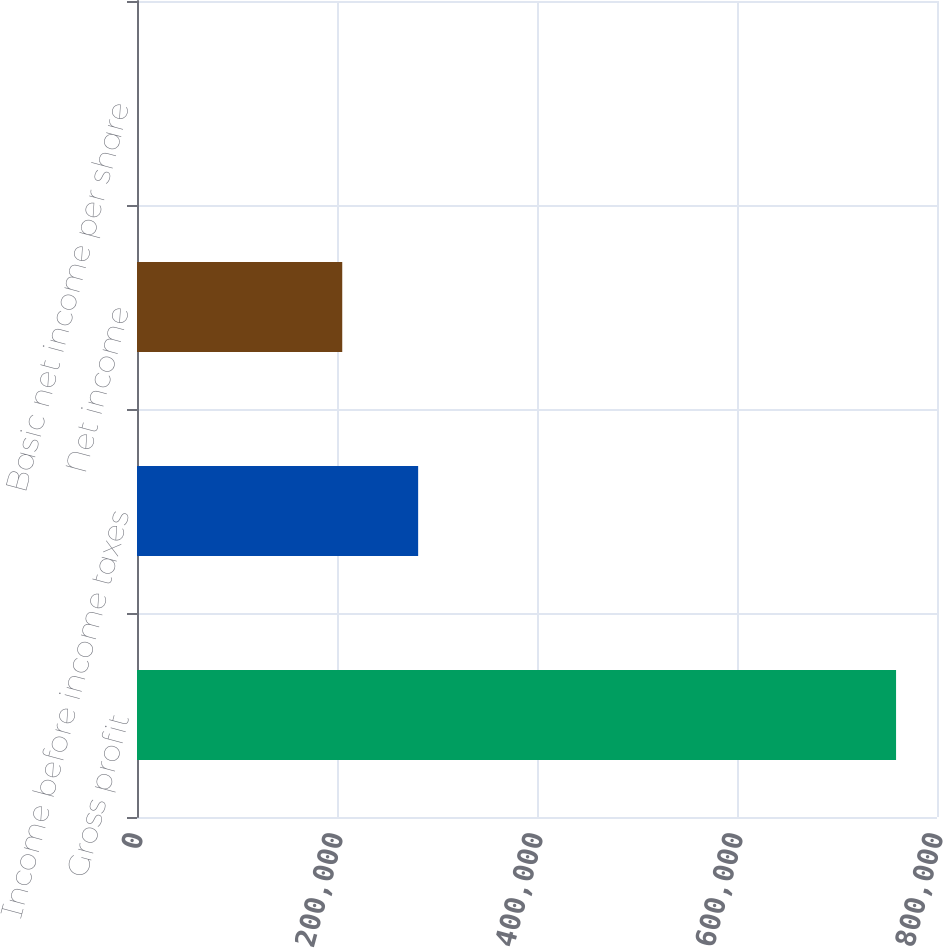Convert chart. <chart><loc_0><loc_0><loc_500><loc_500><bar_chart><fcel>Gross profit<fcel>Income before income taxes<fcel>Net income<fcel>Basic net income per share<nl><fcel>759065<fcel>281149<fcel>205243<fcel>0.35<nl></chart> 